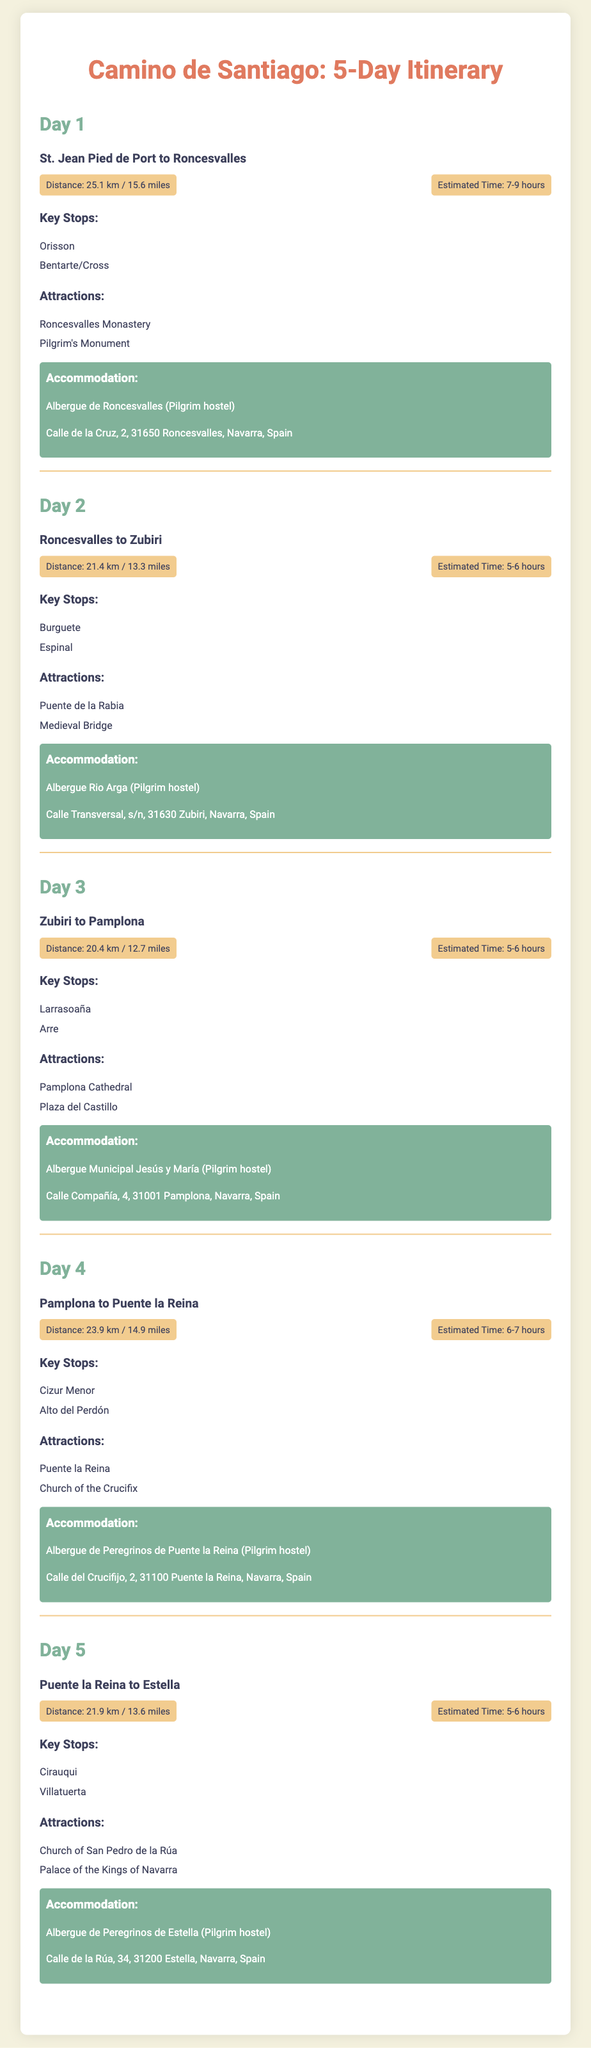what is the distance from St. Jean Pied de Port to Roncesvalles? The document specifies the distance for Day 1 as 25.1 km / 15.6 miles.
Answer: 25.1 km / 15.6 miles how many hours is the estimated time for walking from Roncesvalles to Zubiri? The document states that the estimated time for Day 2 is 5-6 hours.
Answer: 5-6 hours what is a key stop on Day 3? The itinerary lists Larrasoaña as one of the key stops for Day 3.
Answer: Larrasoaña which accommodation is listed for Pamplona? The document mentions Albergue Municipal Jesús y María as the accommodation in Pamplona.
Answer: Albergue Municipal Jesús y María what attraction can be found at Puente la Reina? An attraction listed for Puente la Reina is the Church of the Crucifix.
Answer: Church of the Crucifix which day involves the longest distance to walk? Comparing all distances, Day 1 has the longest distance at 25.1 km.
Answer: Day 1 how many key stops are listed for Day 4? The document indicates 2 key stops for Day 4, which are Cizur Menor and Alto del Perdón.
Answer: 2 key stops what is the total distance covered from Puente la Reina to Estella? The document specifies the distance for Day 5 as 21.9 km / 13.6 miles.
Answer: 21.9 km / 13.6 miles 